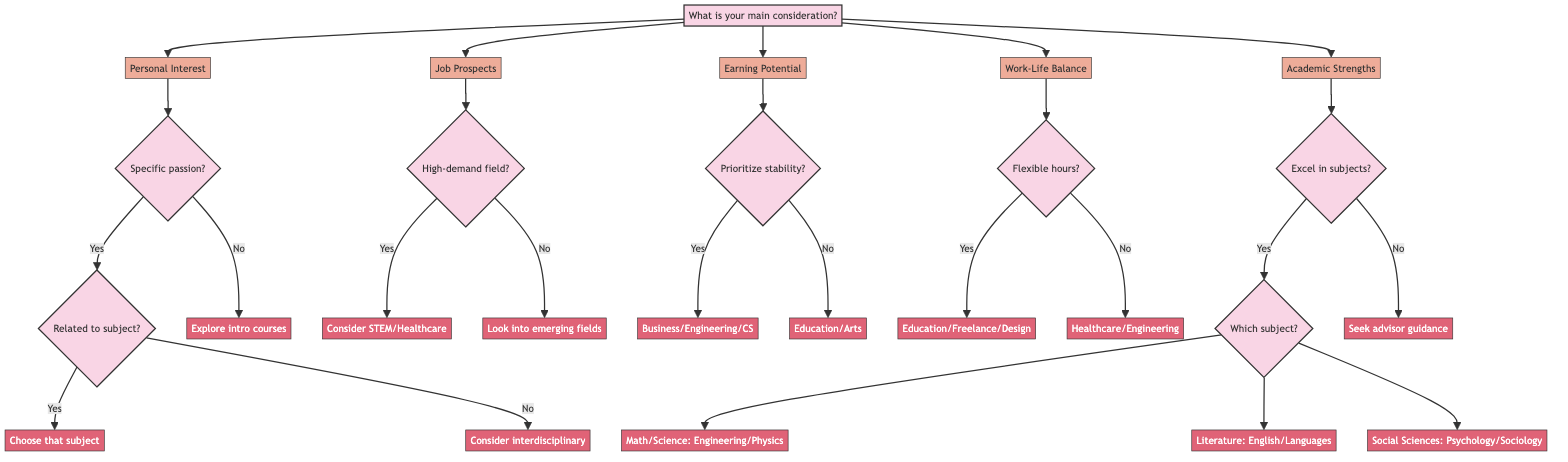What is the first question in the diagram? The first question in the diagram is asked at node A: "What is your main consideration when choosing a major?" This is the starting point for all subsequent choices and branches.
Answer: What is your main consideration when choosing a major? How many main considerations are listed in the diagram? The main considerations listed at node A are five: Personal Interest, Job Prospects, Earning Potential, Work-Life Balance, and Academic Strengths. Therefore, the count of main considerations is five.
Answer: Five If the answer is "No" to having a specific passion, what is the next step? If the answer is "No" to having a specific passion (node G), it leads to node I, which suggests exploring introductory courses in different subjects to find your interest.
Answer: Explore introductory courses in different subjects What majors should you consider if you excel in Math and Science? If you excel in Math and Science (node V), the decision tree leads to node X, which suggests considering majors like Engineering, Physics, or Chemistry.
Answer: Engineering, Physics, or Chemistry What should you consider if you prioritize long-term financial stability? If you prioritize long-term financial stability (node O), the decision path leads to node P, which recommends considering majors like Business, Engineering, or Computer Science.
Answer: Business, Engineering, or Computer Science What professions are suggested if you value flexible work hours? According to node R, if you value flexible work hours (answering "Yes"), the flow indicates considering professions like Education, Freelance Writing, or Graphic Design, which can offer this flexibility.
Answer: Education, Freelance Writing, or Graphic Design If you are interested in a high-demand field, what majors are recommended? If you answer "Yes" to looking for a high-demand field (node L), the recommendations include considering majors in STEM fields or Healthcare as per node M.
Answer: STEM fields or Healthcare What happens if you do not excel in any subjects? If the answer is "No" to excelling in any subjects (node U), the diagram suggests seeking guidance from academic advisors and exploring different disciplines, as indicated in node W.
Answer: Seek guidance from academic advisors If I want to look into emerging fields, what should I prioritize? If I don't prioritize high-demand fields (node L), the diagram suggests looking into emerging fields or niche areas that interest you, leading to node N.
Answer: Look into emerging fields 